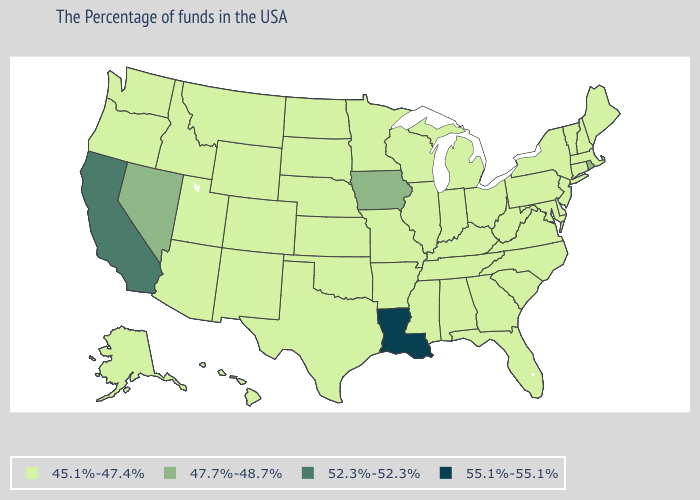Does the map have missing data?
Concise answer only. No. Which states have the highest value in the USA?
Quick response, please. Louisiana. What is the lowest value in the South?
Concise answer only. 45.1%-47.4%. Among the states that border Vermont , which have the highest value?
Write a very short answer. Massachusetts, New Hampshire, New York. What is the value of Montana?
Write a very short answer. 45.1%-47.4%. What is the lowest value in the MidWest?
Be succinct. 45.1%-47.4%. Name the states that have a value in the range 45.1%-47.4%?
Concise answer only. Maine, Massachusetts, New Hampshire, Vermont, Connecticut, New York, New Jersey, Delaware, Maryland, Pennsylvania, Virginia, North Carolina, South Carolina, West Virginia, Ohio, Florida, Georgia, Michigan, Kentucky, Indiana, Alabama, Tennessee, Wisconsin, Illinois, Mississippi, Missouri, Arkansas, Minnesota, Kansas, Nebraska, Oklahoma, Texas, South Dakota, North Dakota, Wyoming, Colorado, New Mexico, Utah, Montana, Arizona, Idaho, Washington, Oregon, Alaska, Hawaii. Name the states that have a value in the range 45.1%-47.4%?
Write a very short answer. Maine, Massachusetts, New Hampshire, Vermont, Connecticut, New York, New Jersey, Delaware, Maryland, Pennsylvania, Virginia, North Carolina, South Carolina, West Virginia, Ohio, Florida, Georgia, Michigan, Kentucky, Indiana, Alabama, Tennessee, Wisconsin, Illinois, Mississippi, Missouri, Arkansas, Minnesota, Kansas, Nebraska, Oklahoma, Texas, South Dakota, North Dakota, Wyoming, Colorado, New Mexico, Utah, Montana, Arizona, Idaho, Washington, Oregon, Alaska, Hawaii. Does Alaska have a lower value than Rhode Island?
Write a very short answer. Yes. What is the value of Idaho?
Quick response, please. 45.1%-47.4%. Does North Dakota have a lower value than Delaware?
Be succinct. No. What is the lowest value in the USA?
Short answer required. 45.1%-47.4%. Among the states that border Arkansas , does Tennessee have the lowest value?
Give a very brief answer. Yes. What is the value of Kansas?
Quick response, please. 45.1%-47.4%. How many symbols are there in the legend?
Write a very short answer. 4. 